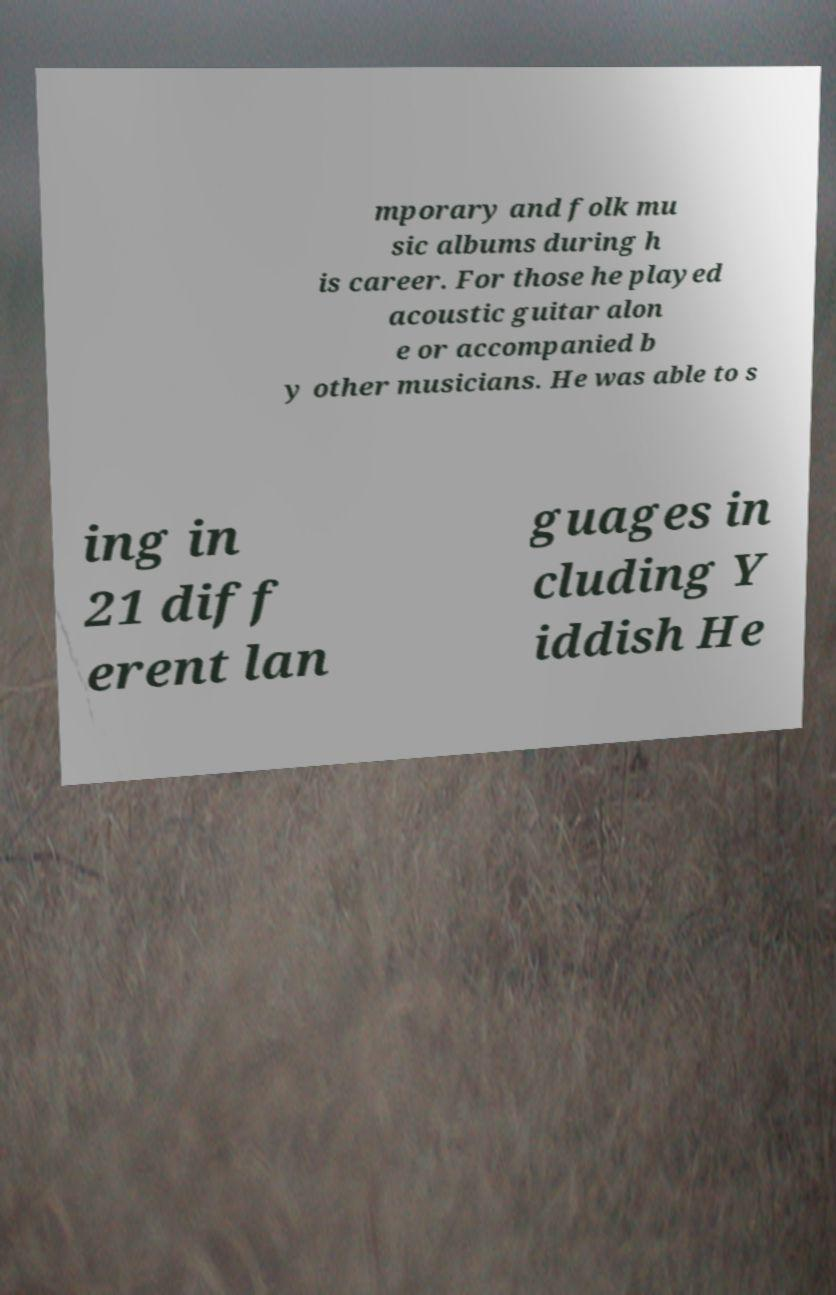Please identify and transcribe the text found in this image. mporary and folk mu sic albums during h is career. For those he played acoustic guitar alon e or accompanied b y other musicians. He was able to s ing in 21 diff erent lan guages in cluding Y iddish He 